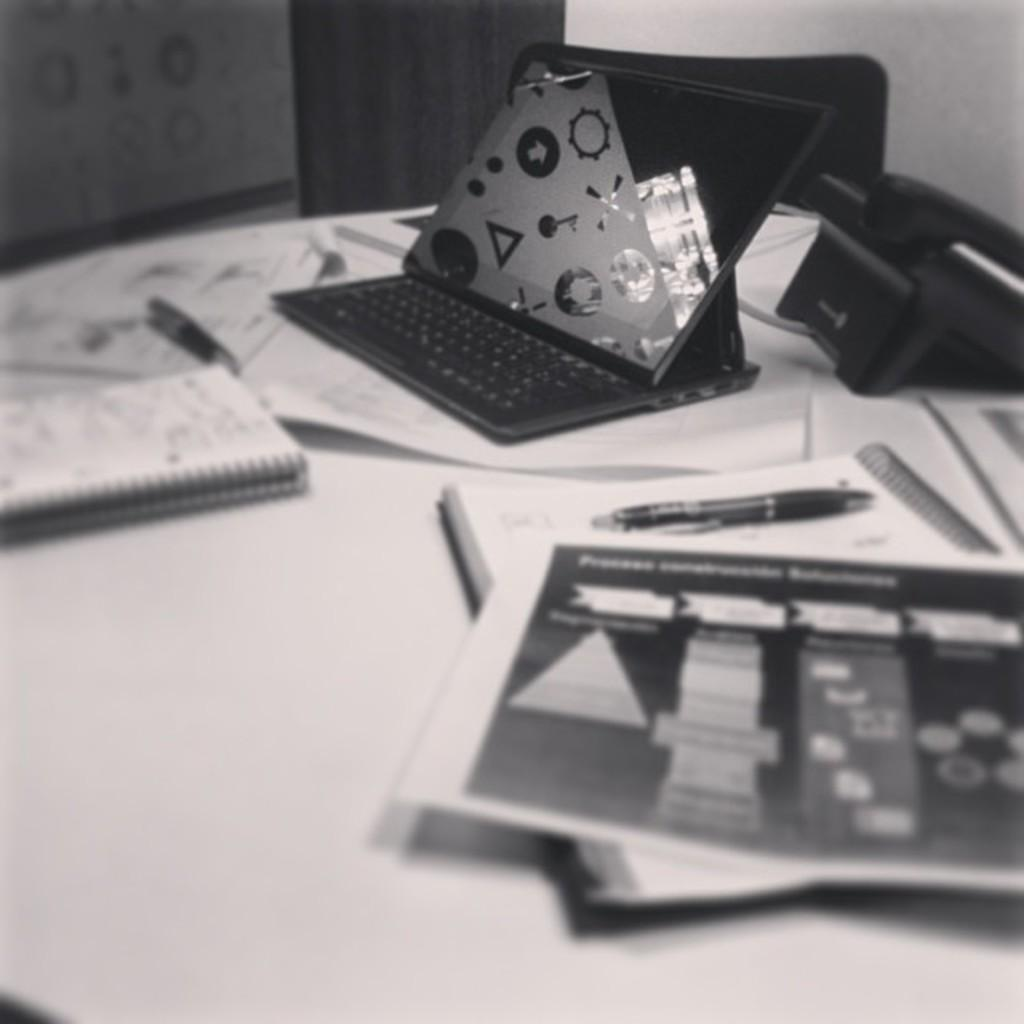What is the color scheme of the image? The image is black and white. What piece of furniture is present in the image? There is a table in the image. What items can be seen on the table? There are books, a pen, a telephone, and a laptop on the table. What type of seating is visible behind the table? There are chairs behind the table. Can you hear the cub whistling in the image? There is no cub or whistling present in the image; it is a black and white image featuring a table with various items on it and chairs behind the table. 